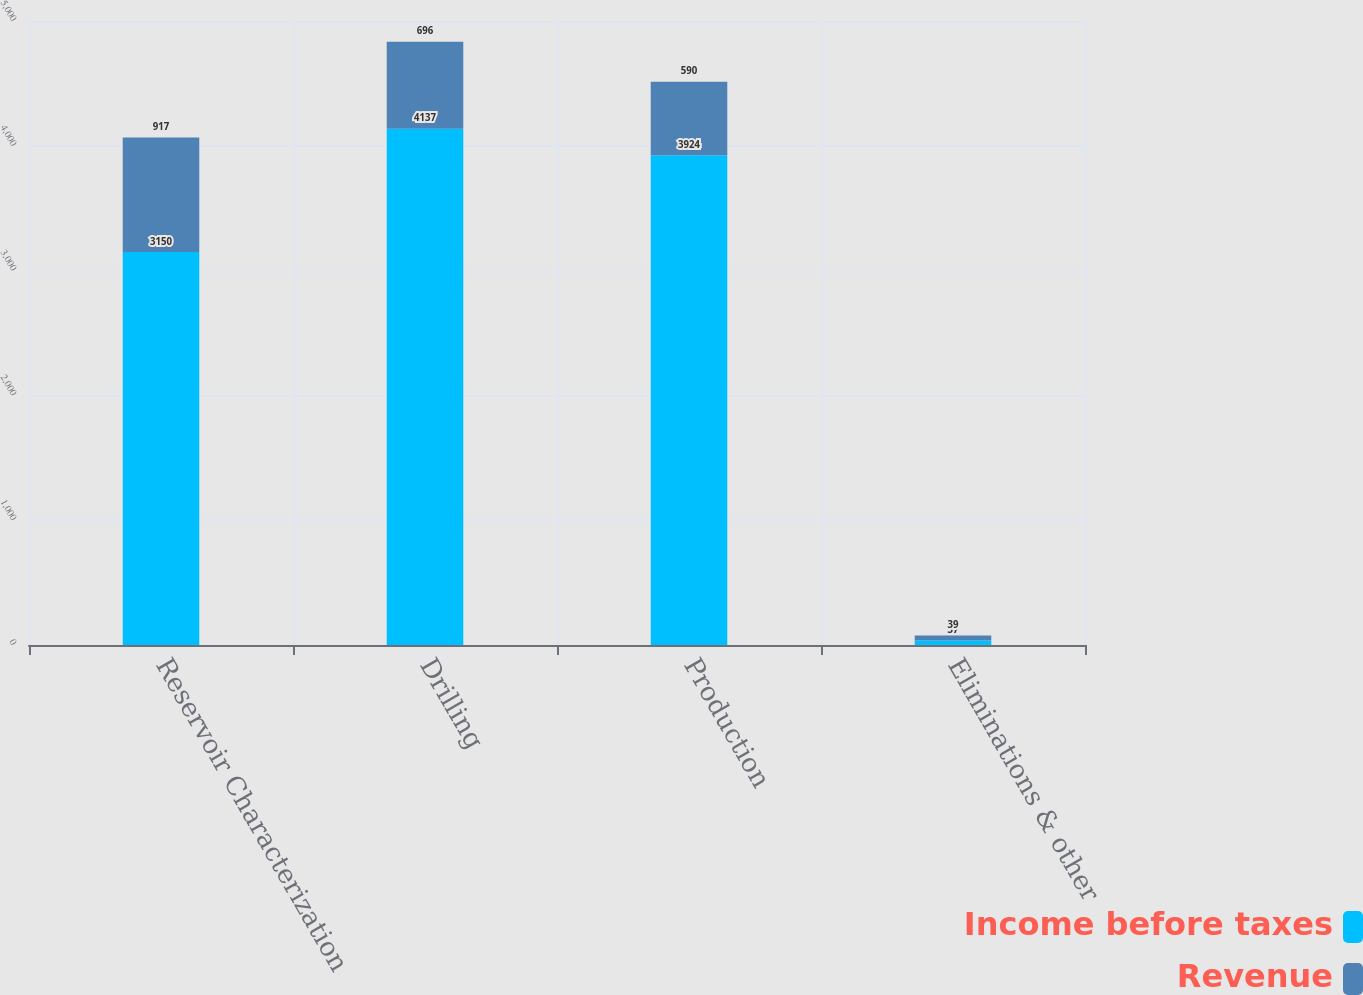Convert chart to OTSL. <chart><loc_0><loc_0><loc_500><loc_500><stacked_bar_chart><ecel><fcel>Reservoir Characterization<fcel>Drilling<fcel>Production<fcel>Eliminations & other<nl><fcel>Income before taxes<fcel>3150<fcel>4137<fcel>3924<fcel>37<nl><fcel>Revenue<fcel>917<fcel>696<fcel>590<fcel>39<nl></chart> 